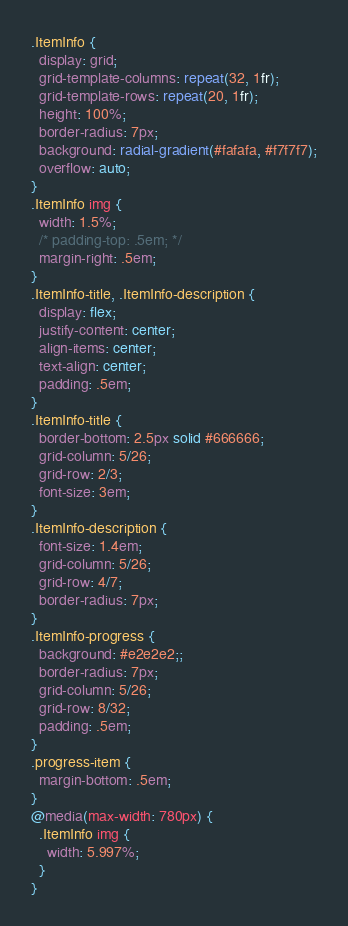<code> <loc_0><loc_0><loc_500><loc_500><_CSS_>.ItemInfo {
  display: grid;
  grid-template-columns: repeat(32, 1fr);
  grid-template-rows: repeat(20, 1fr);
  height: 100%;
  border-radius: 7px;
  background: radial-gradient(#fafafa, #f7f7f7);
  overflow: auto;
}
.ItemInfo img {
  width: 1.5%;
  /* padding-top: .5em; */
  margin-right: .5em;
}
.ItemInfo-title, .ItemInfo-description {
  display: flex;
  justify-content: center;
  align-items: center;
  text-align: center;
  padding: .5em;
}
.ItemInfo-title {
  border-bottom: 2.5px solid #666666;
  grid-column: 5/26;
  grid-row: 2/3;
  font-size: 3em;
}
.ItemInfo-description {
  font-size: 1.4em;
  grid-column: 5/26;
  grid-row: 4/7;
  border-radius: 7px;
}
.ItemInfo-progress {
  background: #e2e2e2;;
  border-radius: 7px;
  grid-column: 5/26;
  grid-row: 8/32;
  padding: .5em;
}
.progress-item {
  margin-bottom: .5em;
}
@media(max-width: 780px) {
  .ItemInfo img {
    width: 5.997%;
  }
}</code> 